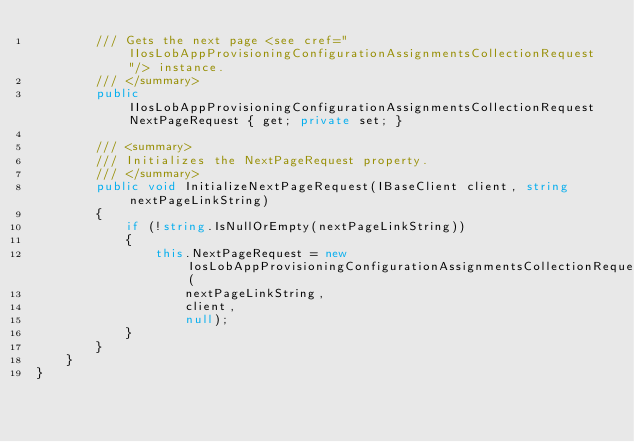Convert code to text. <code><loc_0><loc_0><loc_500><loc_500><_C#_>        /// Gets the next page <see cref="IIosLobAppProvisioningConfigurationAssignmentsCollectionRequest"/> instance.
        /// </summary>
        public IIosLobAppProvisioningConfigurationAssignmentsCollectionRequest NextPageRequest { get; private set; }

        /// <summary>
        /// Initializes the NextPageRequest property.
        /// </summary>
        public void InitializeNextPageRequest(IBaseClient client, string nextPageLinkString)
        {
            if (!string.IsNullOrEmpty(nextPageLinkString))
            {
                this.NextPageRequest = new IosLobAppProvisioningConfigurationAssignmentsCollectionRequest(
                    nextPageLinkString,
                    client,
                    null);
            }
        }
    }
}
</code> 